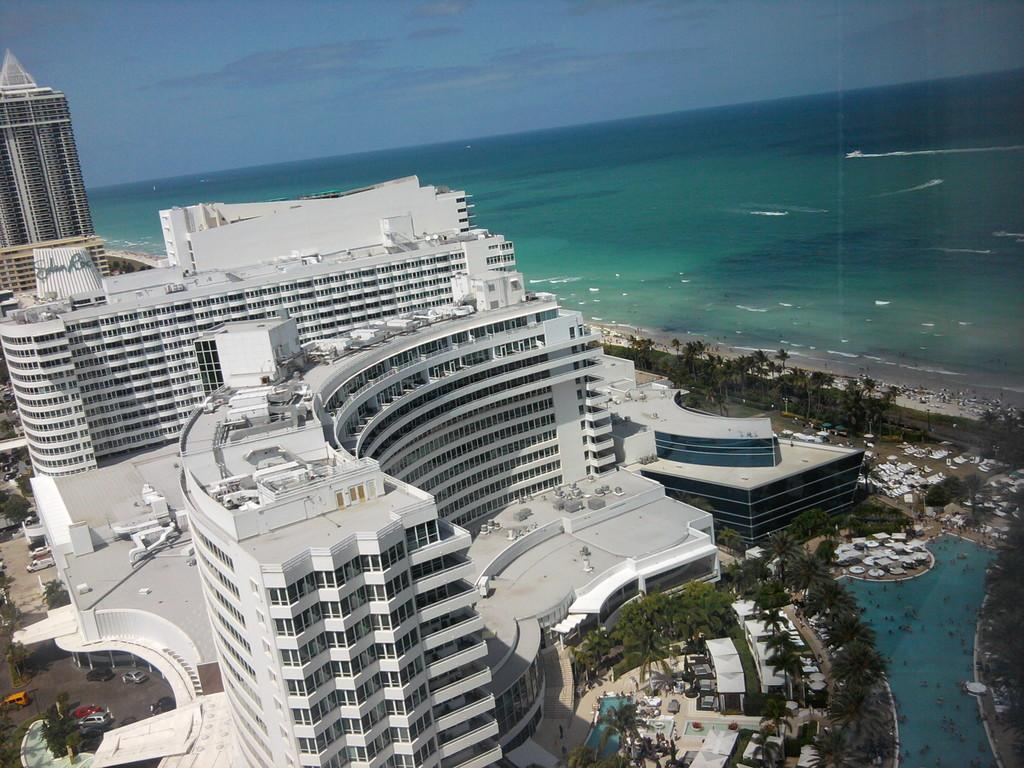What colors are used for the buildings in the image? The buildings in the image are in white and cream color. What can be seen moving on the road in the image? There are vehicles on the road in the image. What type of vegetation is present in the image? There are trees with green color in the image. What body of water is visible in the image? There is water with blue color in the image. What color is the sky in the background of the image? The sky in the background of the image is blue. How many legs can be seen on the clock in the image? There is no clock present in the image, so it is not possible to determine the number of legs on a clock. What type of creature is pulling the water in the image? There is no creature present in the image, and the water is not being pulled by any entity. 